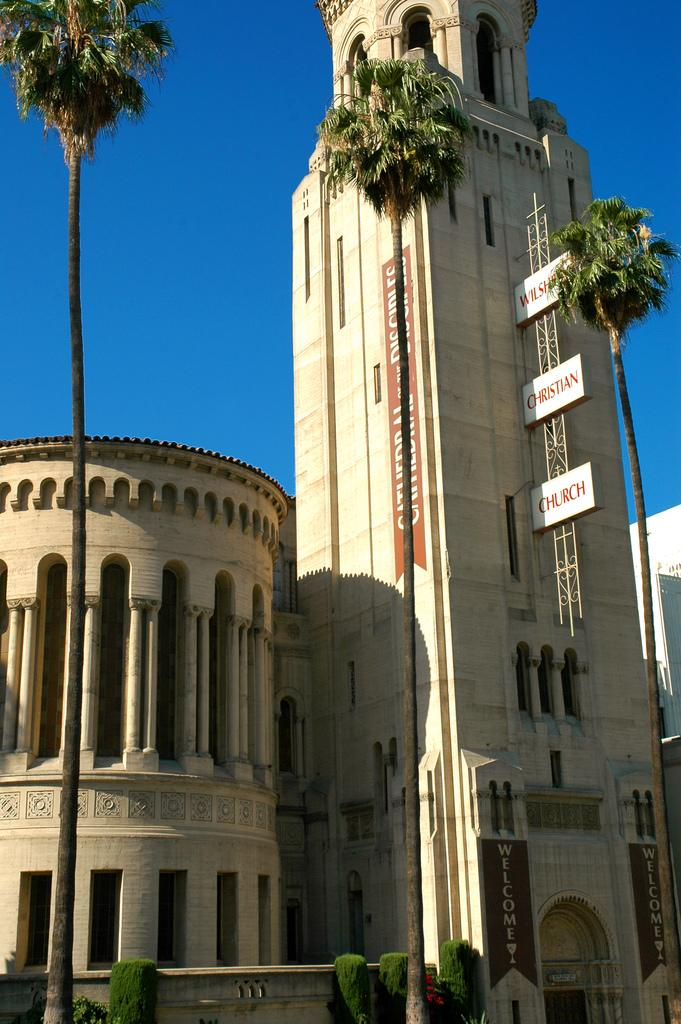What type of structures can be seen in the image? There are buildings in the image. What other objects are present in the image? There are boards and trees visible in the image. What can be seen in the background of the image? The sky is visible in the background of the image. How does the selection process work for the stocking of the trees in the image? There is no mention of a selection process or stocking of trees in the image; it simply shows buildings, boards, trees, and the sky. 